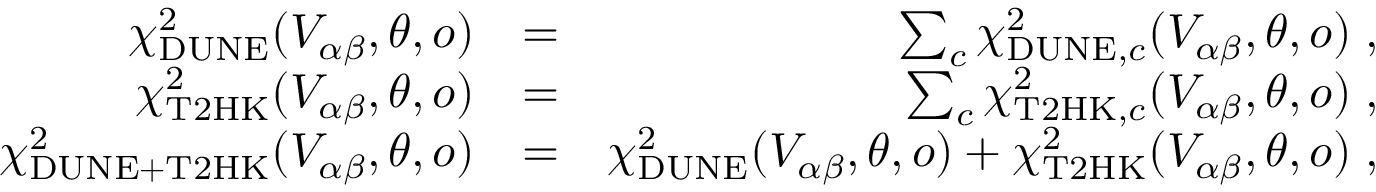<formula> <loc_0><loc_0><loc_500><loc_500>\begin{array} { r l r } { \chi _ { D U N E } ^ { 2 } ( V _ { \alpha \beta } , \theta , o ) } & { = } & { \sum _ { c } \chi _ { D U N E , c } ^ { 2 } ( V _ { \alpha \beta } , \theta , o ) \, , } \\ { \chi _ { T 2 H K } ^ { 2 } ( V _ { \alpha \beta } , \theta , o ) } & { = } & { \sum _ { c } \chi _ { T 2 H K , c } ^ { 2 } ( V _ { \alpha \beta } , \theta , o ) \, , } \\ { \chi _ { D U N E + T 2 H K } ^ { 2 } ( V _ { \alpha \beta } , \theta , o ) } & { = } & { \chi _ { D U N E } ^ { 2 } ( V _ { \alpha \beta } , \theta , o ) + \chi _ { T 2 H K } ^ { 2 } ( V _ { \alpha \beta } , \theta , o ) \, , } \end{array}</formula> 